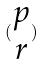<formula> <loc_0><loc_0><loc_500><loc_500>( \begin{matrix} p \\ r \end{matrix} )</formula> 